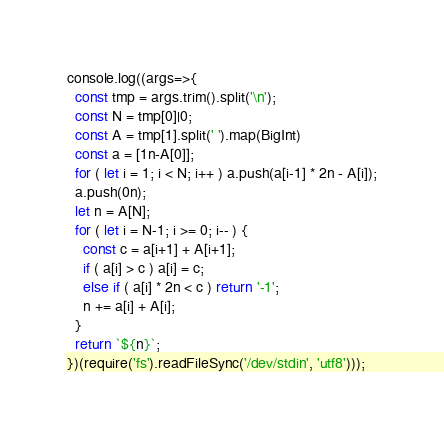Convert code to text. <code><loc_0><loc_0><loc_500><loc_500><_JavaScript_>console.log((args=>{
  const tmp = args.trim().split('\n');
  const N = tmp[0]|0;
  const A = tmp[1].split(' ').map(BigInt)
  const a = [1n-A[0]];
  for ( let i = 1; i < N; i++ ) a.push(a[i-1] * 2n - A[i]);
  a.push(0n);
  let n = A[N];
  for ( let i = N-1; i >= 0; i-- ) {
    const c = a[i+1] + A[i+1];
    if ( a[i] > c ) a[i] = c;
    else if ( a[i] * 2n < c ) return '-1';
    n += a[i] + A[i];
  }
  return `${n}`;
})(require('fs').readFileSync('/dev/stdin', 'utf8')));
</code> 